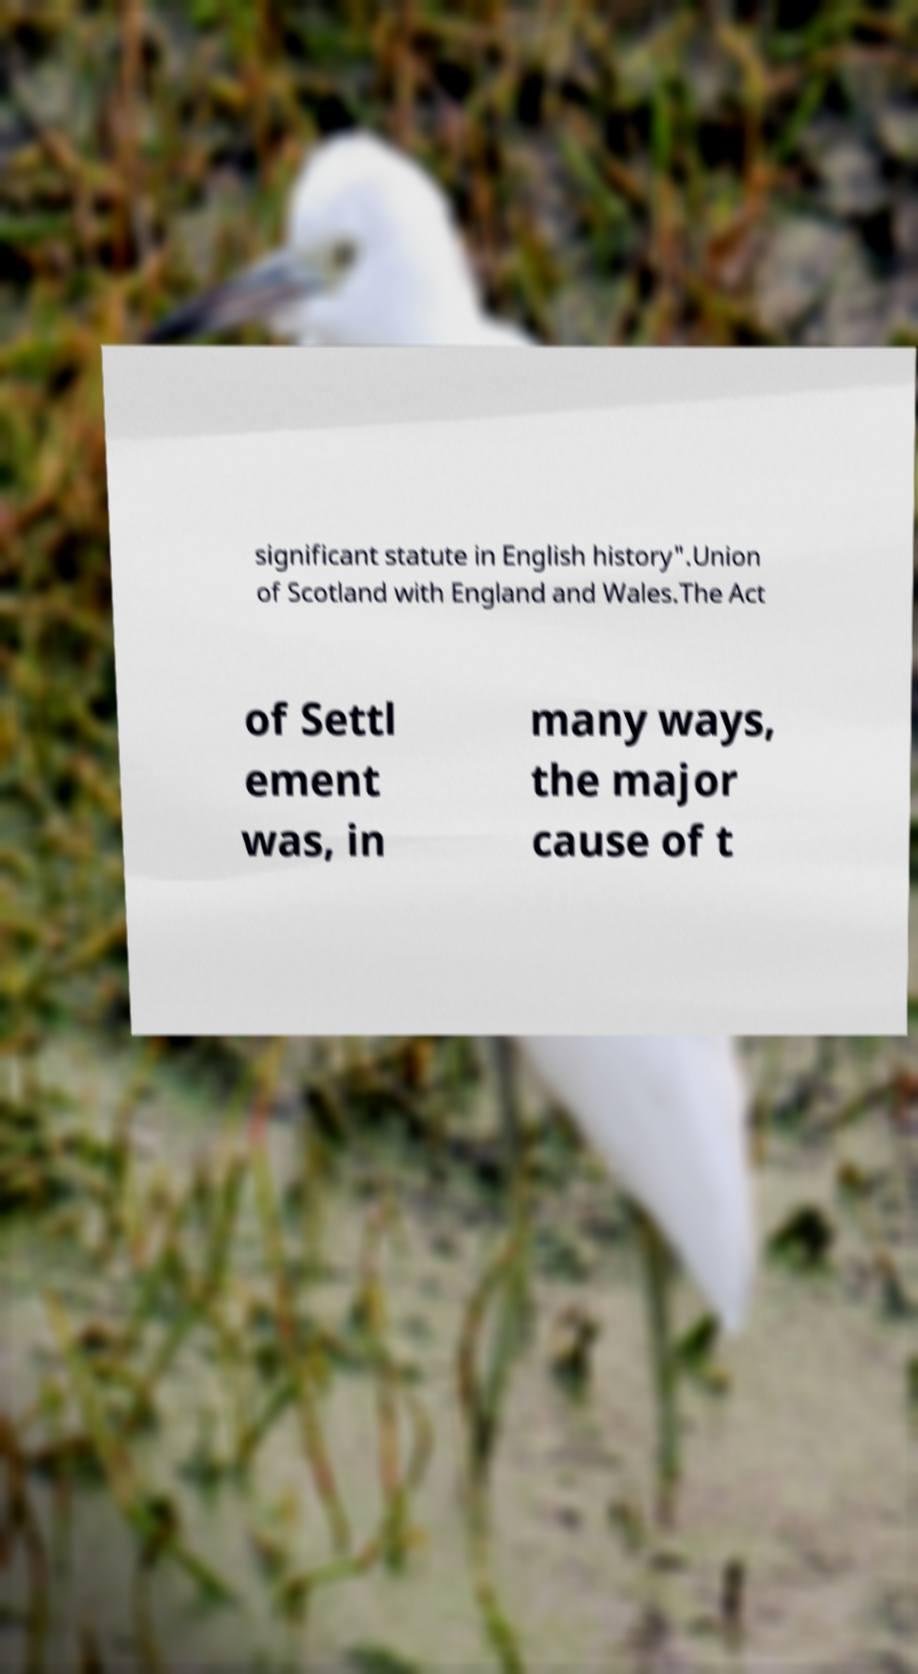Can you accurately transcribe the text from the provided image for me? significant statute in English history".Union of Scotland with England and Wales.The Act of Settl ement was, in many ways, the major cause of t 